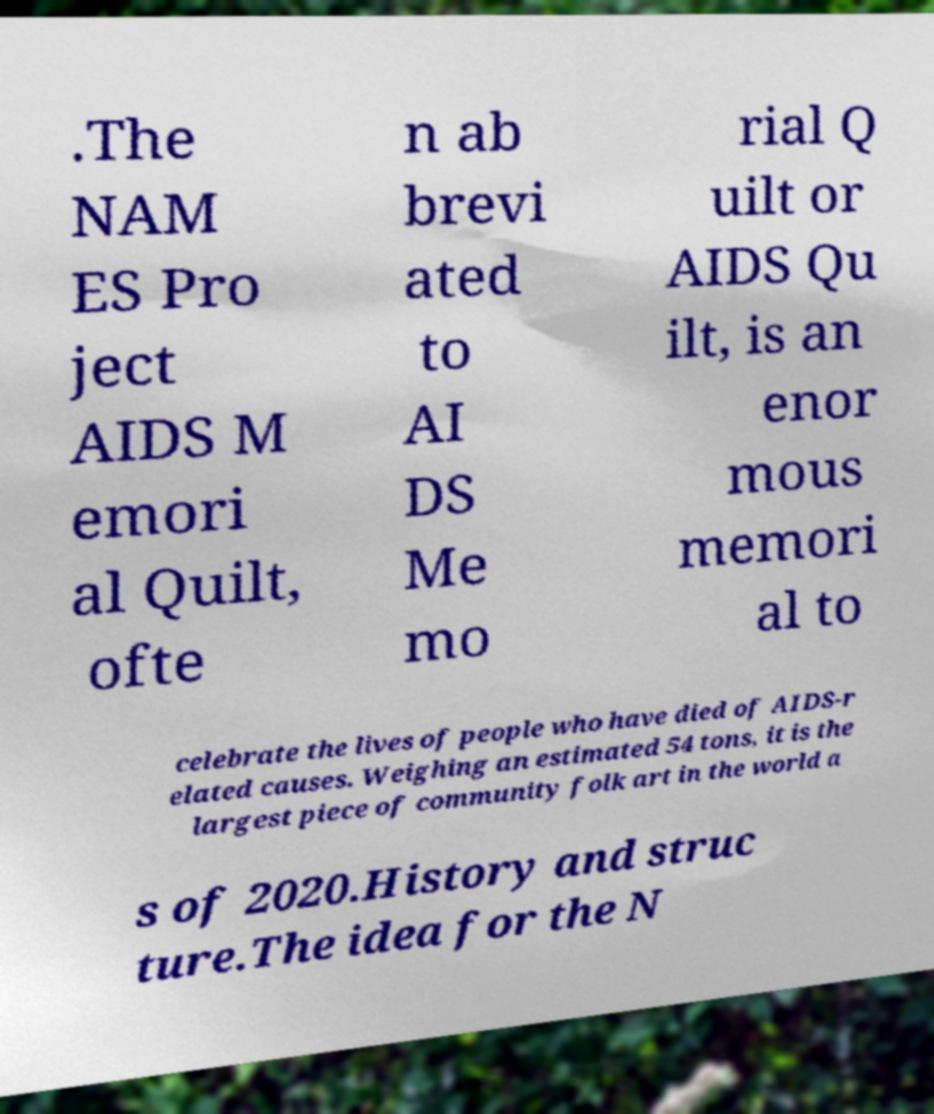Can you read and provide the text displayed in the image?This photo seems to have some interesting text. Can you extract and type it out for me? .The NAM ES Pro ject AIDS M emori al Quilt, ofte n ab brevi ated to AI DS Me mo rial Q uilt or AIDS Qu ilt, is an enor mous memori al to celebrate the lives of people who have died of AIDS-r elated causes. Weighing an estimated 54 tons, it is the largest piece of community folk art in the world a s of 2020.History and struc ture.The idea for the N 